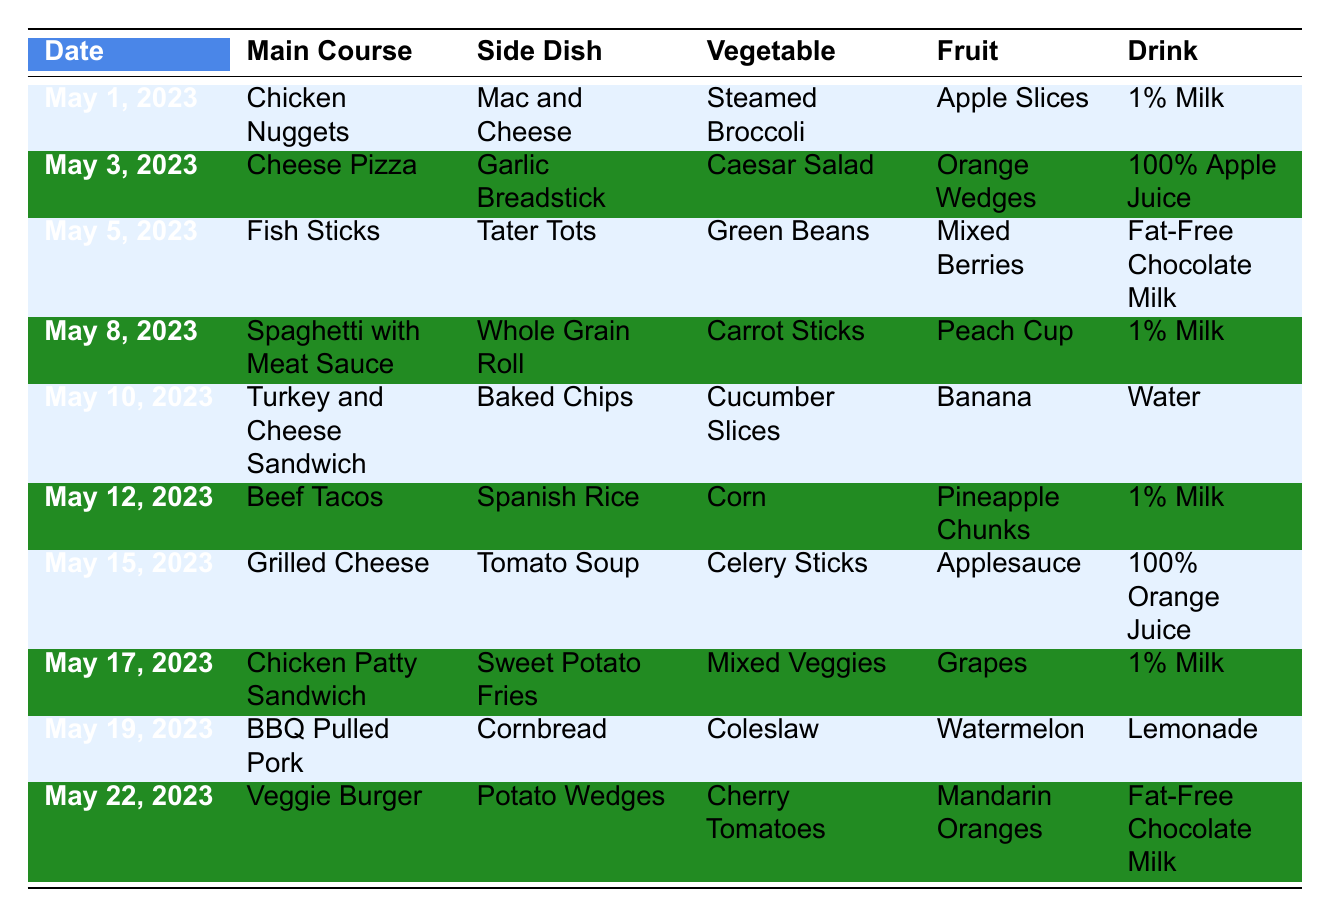What is the main course on May 8, 2023? Looking at the row for May 8, 2023, the main course listed is "Spaghetti with Meat Sauce."
Answer: Spaghetti with Meat Sauce What drink is served with the Chicken Nuggets on May 1, 2023? In the row for May 1, 2023, Chicken Nuggets is the main course, and the corresponding drink listed is "1% Milk."
Answer: 1% Milk Which fruit is served with the Beef Tacos on May 12, 2023? Referring to the row for May 12, 2023, the fruit served with Beef Tacos is "Pineapple Chunks."
Answer: Pineapple Chunks Is there any day when a Veggie Burger is served? Looking through the table, the Veggie Burger is served on May 22, 2023, confirming that there is a day when it is served.
Answer: Yes What are the side dishes served on May 5 and May 19, 2023? On May 5, 2023, the side dish is "Tater Tots," while on May 19, 2023, it is "Cornbread."
Answer: Tater Tots and Cornbread Which day has both 1% Milk and a main course of grilled cheese? Checking the table shows that 1% Milk is served on multiple days, but with grilled cheese, it only appears on May 15, 2023.
Answer: May 15, 2023 What is the total number of different main courses served in this table? The main courses listed are Chicken Nuggets, Cheese Pizza, Fish Sticks, Spaghetti with Meat Sauce, Turkey and Cheese Sandwich, Beef Tacos, Grilled Cheese, Chicken Patty Sandwich, BBQ Pulled Pork, and Veggie Burger. This gives us 10 different main courses.
Answer: 10 On which dates is 1% Milk served? 1% Milk is served on May 1, May 8, May 12, and May 17, 2023, when checking the corresponding rows for these dates in the drink column.
Answer: May 1, 8, 12, 17, 2023 How many fruit options are served between May 1 and May 10, 2023? The fruits served during this period are Apple Slices (May 1), Orange Wedges (May 3), Mixed Berries (May 5), Peach Cup (May 8), and Banana (May 10), giving us a total of 5 unique options.
Answer: 5 Is there a day when the main course is Fish Sticks, and what is the side dish served that day? Fish Sticks appears on May 5, 2023, and the side dish served with it that day is "Tater Tots."
Answer: May 5, 2023; Tater Tots Which vegetable is served with the BBQ Pulled Pork on May 19, 2023? The vegetable listed for BBQ Pulled Pork on May 19, 2023, is "Coleslaw."
Answer: Coleslaw What is the most common drink served across the menu? The drinks listed are 1% Milk, 100% Apple Juice, Fat-Free Chocolate Milk, Water, and 100% Orange Juice. Counting shows 1% Milk is served 4 times, making it the most common drink.
Answer: 1% Milk 